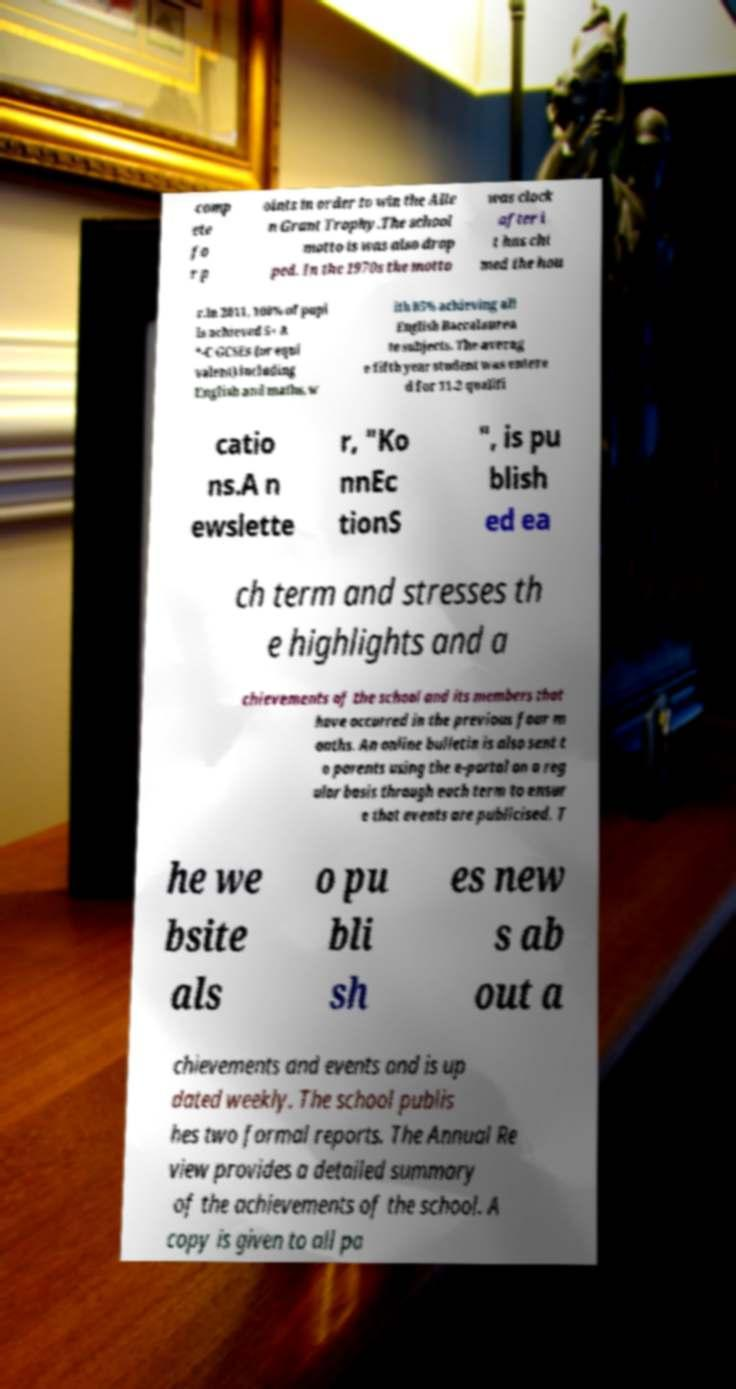I need the written content from this picture converted into text. Can you do that? comp ete fo r p oints in order to win the Alle n Grant Trophy.The school motto is was also drop ped. In the 1970s the motto was clock after i t has chi med the hou r.In 2011, 100% of pupi ls achieved 5+ A *-C GCSEs (or equi valent) including English and maths, w ith 85% achieving all English Baccalaurea te subjects. The averag e fifth year student was entere d for 11.2 qualifi catio ns.A n ewslette r, "Ko nnEc tionS ", is pu blish ed ea ch term and stresses th e highlights and a chievements of the school and its members that have occurred in the previous four m onths. An online bulletin is also sent t o parents using the e-portal on a reg ular basis through each term to ensur e that events are publicised. T he we bsite als o pu bli sh es new s ab out a chievements and events and is up dated weekly. The school publis hes two formal reports. The Annual Re view provides a detailed summary of the achievements of the school. A copy is given to all pa 